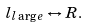<formula> <loc_0><loc_0><loc_500><loc_500>l _ { l \arg e } \leftrightarrow R .</formula> 